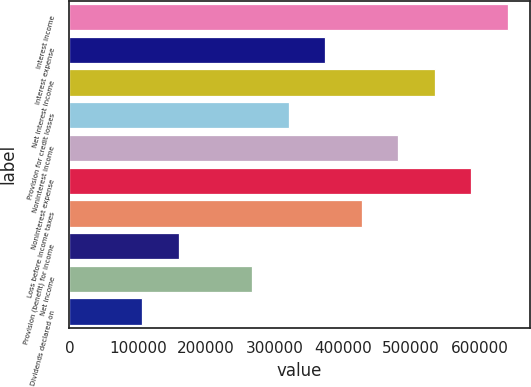Convert chart to OTSL. <chart><loc_0><loc_0><loc_500><loc_500><bar_chart><fcel>Interest income<fcel>Interest expense<fcel>Net interest income<fcel>Provision for credit losses<fcel>Noninterest income<fcel>Noninterest expense<fcel>Loss before income taxes<fcel>Provision (benefit) for income<fcel>Net income<fcel>Dividends declared on<nl><fcel>641603<fcel>374268<fcel>534669<fcel>320801<fcel>481202<fcel>588136<fcel>427735<fcel>160401<fcel>267335<fcel>106934<nl></chart> 